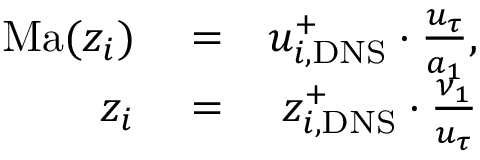Convert formula to latex. <formula><loc_0><loc_0><loc_500><loc_500>\begin{array} { r l r } { M a ( z _ { i } ) } & = } & { u _ { i , D N S } ^ { + } \cdot \frac { u _ { \tau } } { a _ { 1 } } , } \\ { z _ { i } } & = } & { z _ { i , D N S } ^ { + } \cdot \frac { \nu _ { 1 } } { u _ { \tau } } } \end{array}</formula> 